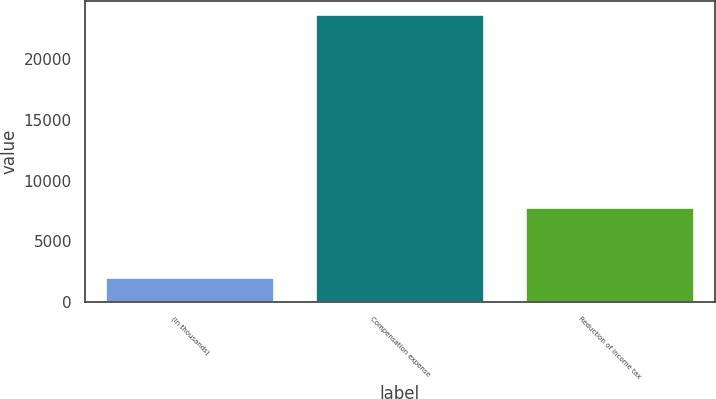Convert chart to OTSL. <chart><loc_0><loc_0><loc_500><loc_500><bar_chart><fcel>(In thousands)<fcel>Compensation expense<fcel>Reduction of income tax<nl><fcel>2014<fcel>23632<fcel>7767<nl></chart> 